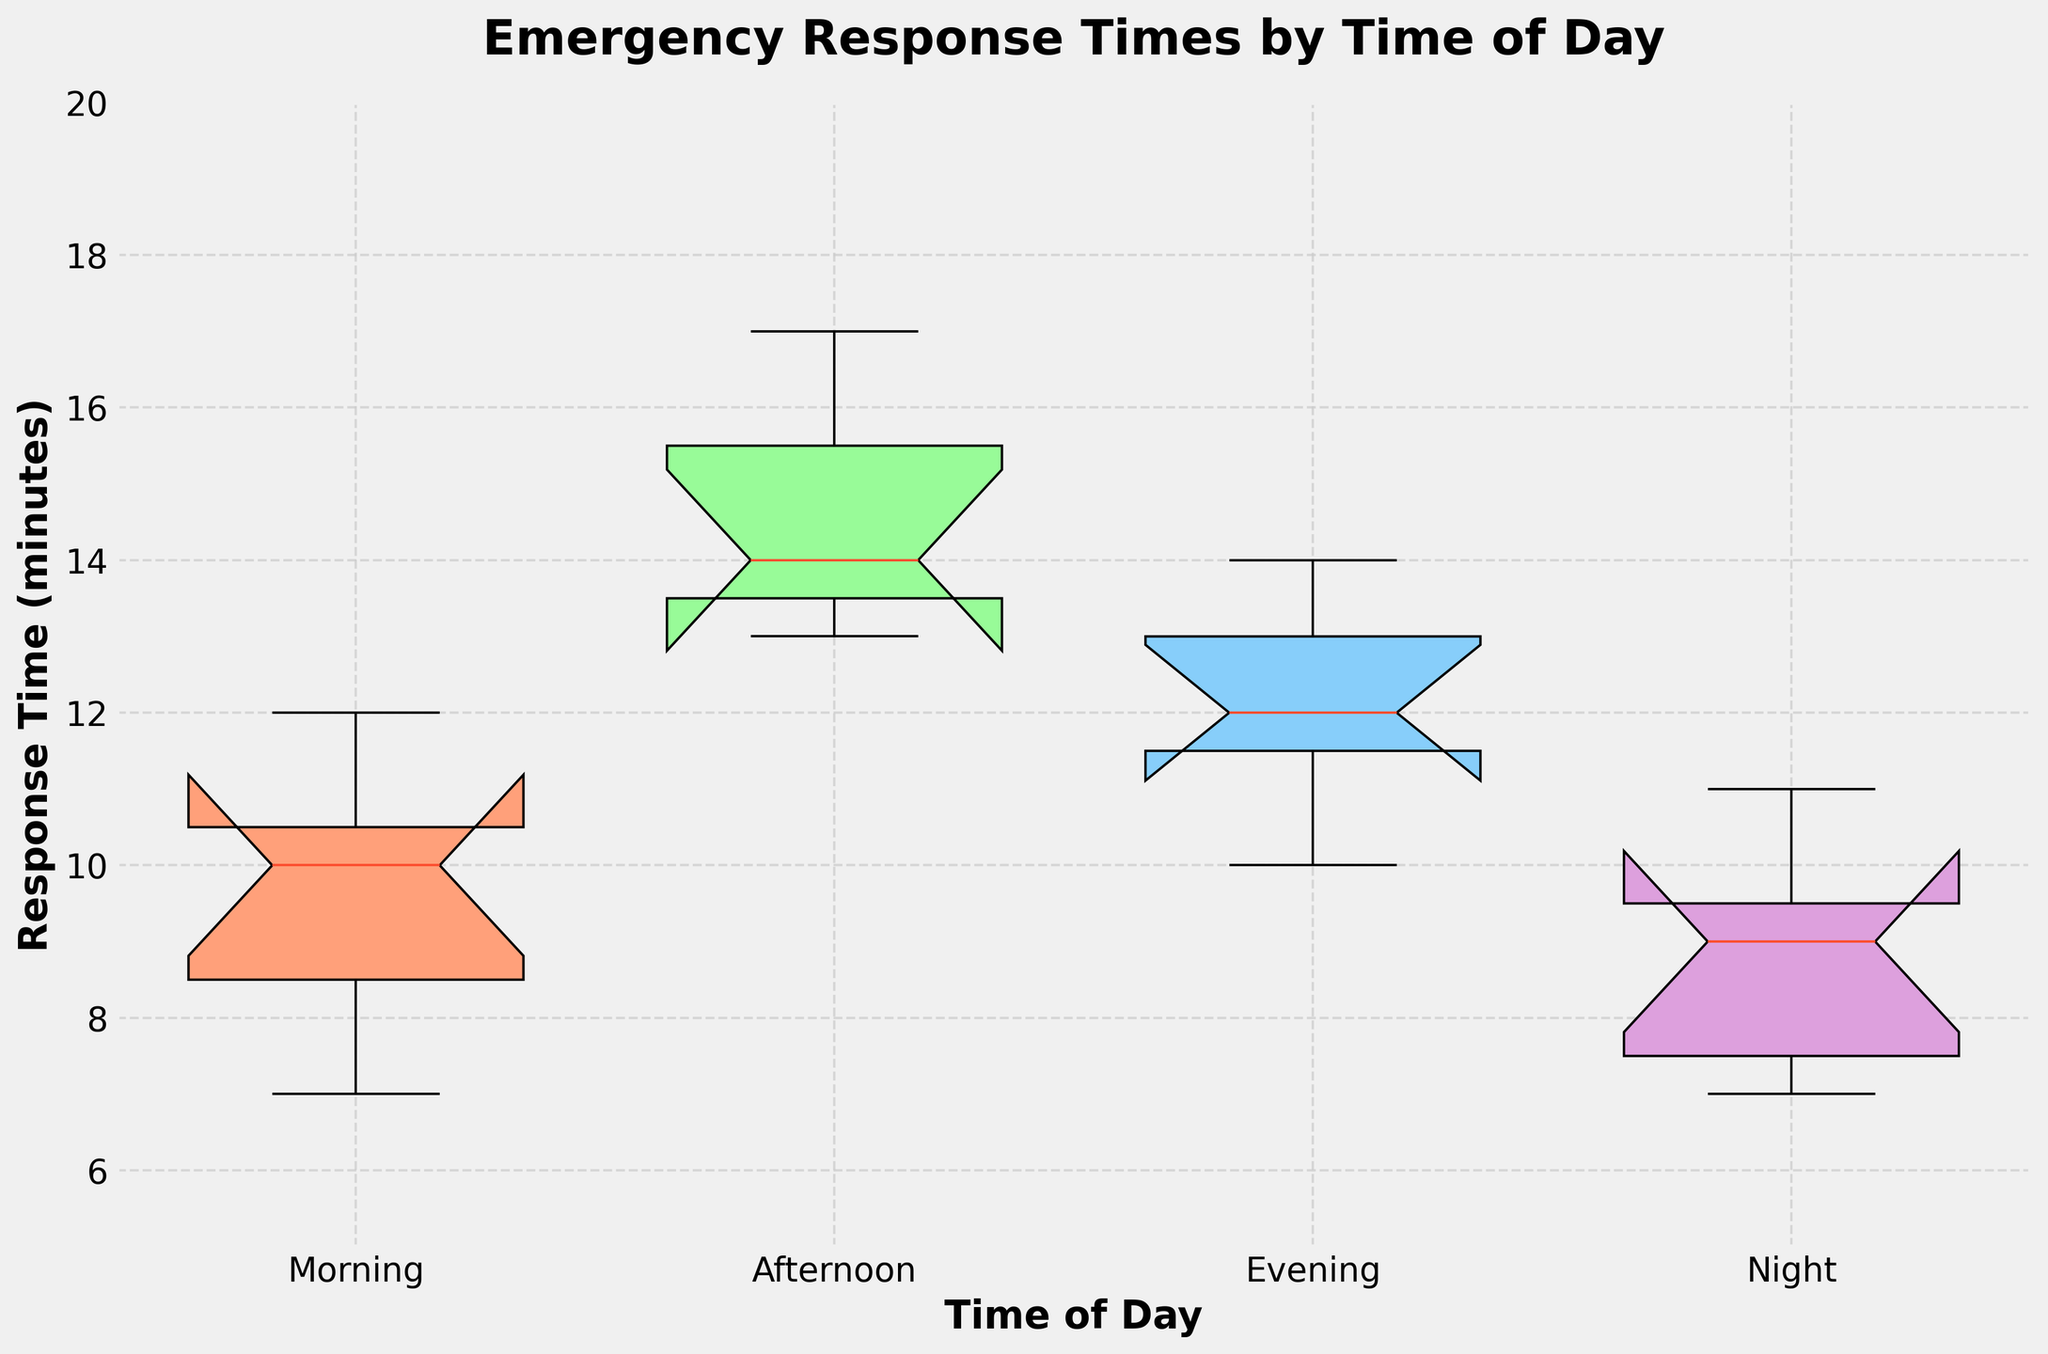What is the title of the figure? The title is found at the top of the figure and provides a summary of what the plot represents. In this case, the title reads "Emergency Response Times by Time of Day."
Answer: Emergency Response Times by Time of Day What are the labels on the x-axis? The labels on the x-axis indicate the different times of day under consideration. These labels help in identifying which box plot corresponds to which period. They are "Morning," "Afternoon," "Evening," and "Night."
Answer: Morning, Afternoon, Evening, Night What is the median response time in the Morning? The median is represented by the line inside each box in the box plot. For the Morning, find the line within the box corresponding to Morning.
Answer: 10 minutes What is the approximate range of response times in the Afternoon? The range is the difference between the maximum and minimum values represented by the top and bottom whiskers of the box plot. For the Afternoon, the range extends approximately from 13 to 17 minutes.
Answer: 4 minutes Which time of day has the lowest median response time? By comparing the lines inside the boxes (which represent medians) for Morning, Afternoon, Evening, and Night, we see that the Night has the lowest median response time.
Answer: Night How does the variability in response times for the Afternoon compare with the Morning? The variability can be assessed by looking at the heights of the boxes and the length of the whiskers. The Afternoon box and whiskers seem to cover a broader range than those for the Morning.
Answer: Afternoon has higher variability What is the interquartile range (IQR) for the Evening? The IQR is the range covered by the box itself, which represents the middle 50% of the data. For the Evening, the IQR extends approximately from 11 to 13.
Answer: 2 minutes Is there any overlap between the response times in the Morning and Night? Since both box plots have some overlap in the notches, it indicates that there is overlap between the response times distributions of the Morning and Night.
Answer: Yes Which time of day has the widest notch? The width of a notch can indicate variation in the data set's median estimation. By comparing notches, the Afternoon has the widest notch.
Answer: Afternoon Are there any outliers in the data? Outliers in box plots are usually indicated with dots outside the whiskers. The whiskers in these box plots extend to the max and min values without any data points outside them.
Answer: No 